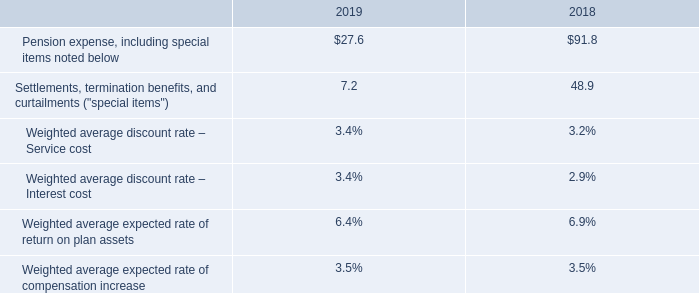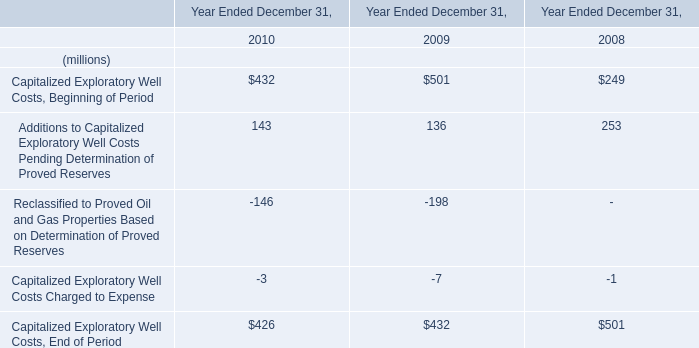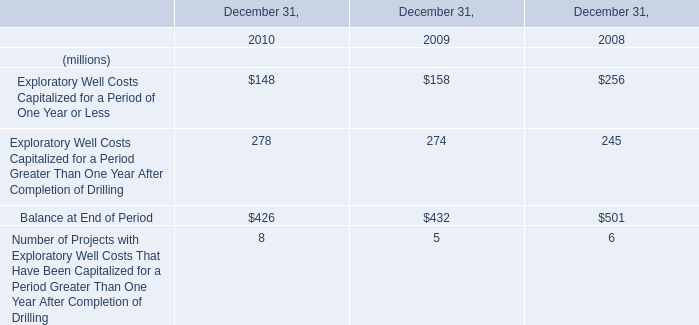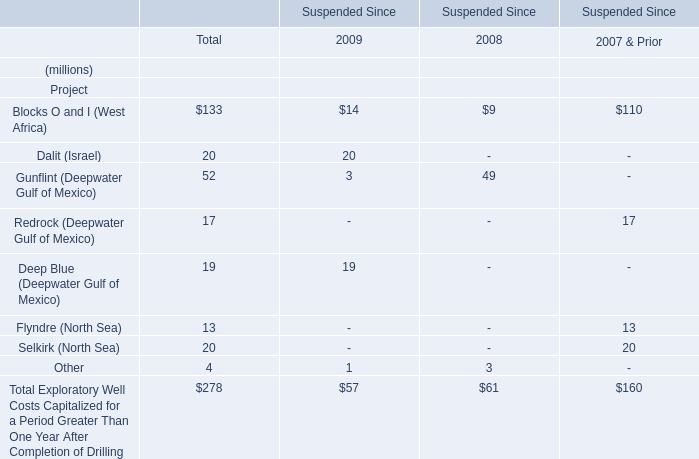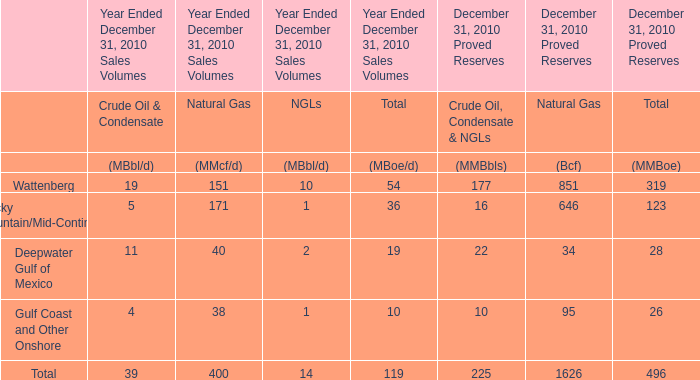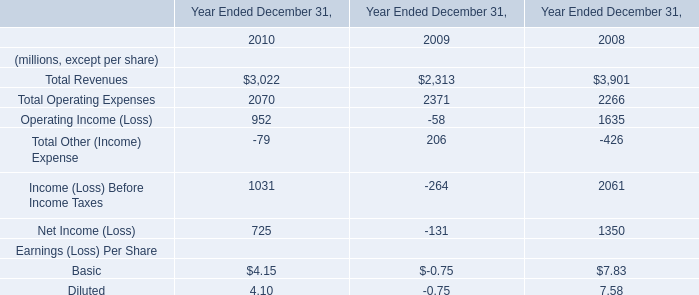What was the average value of Dalit (Israel), Gunflint (Deepwater Gulf of Mexico) and Redrock (Deepwater Gulf of Mexico) in Total ? (in million) 
Computations: (((20 + 52) + 17) / 3)
Answer: 29.66667. 